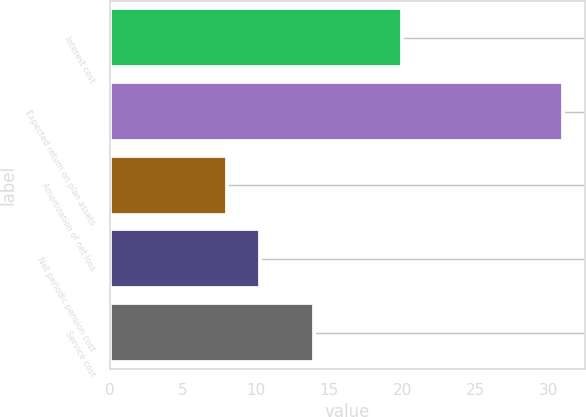Convert chart. <chart><loc_0><loc_0><loc_500><loc_500><bar_chart><fcel>Interest cost<fcel>Expected return on plan assets<fcel>Amortization of net loss<fcel>Net periodic pension cost<fcel>Service cost<nl><fcel>20<fcel>31<fcel>8<fcel>10.3<fcel>14<nl></chart> 